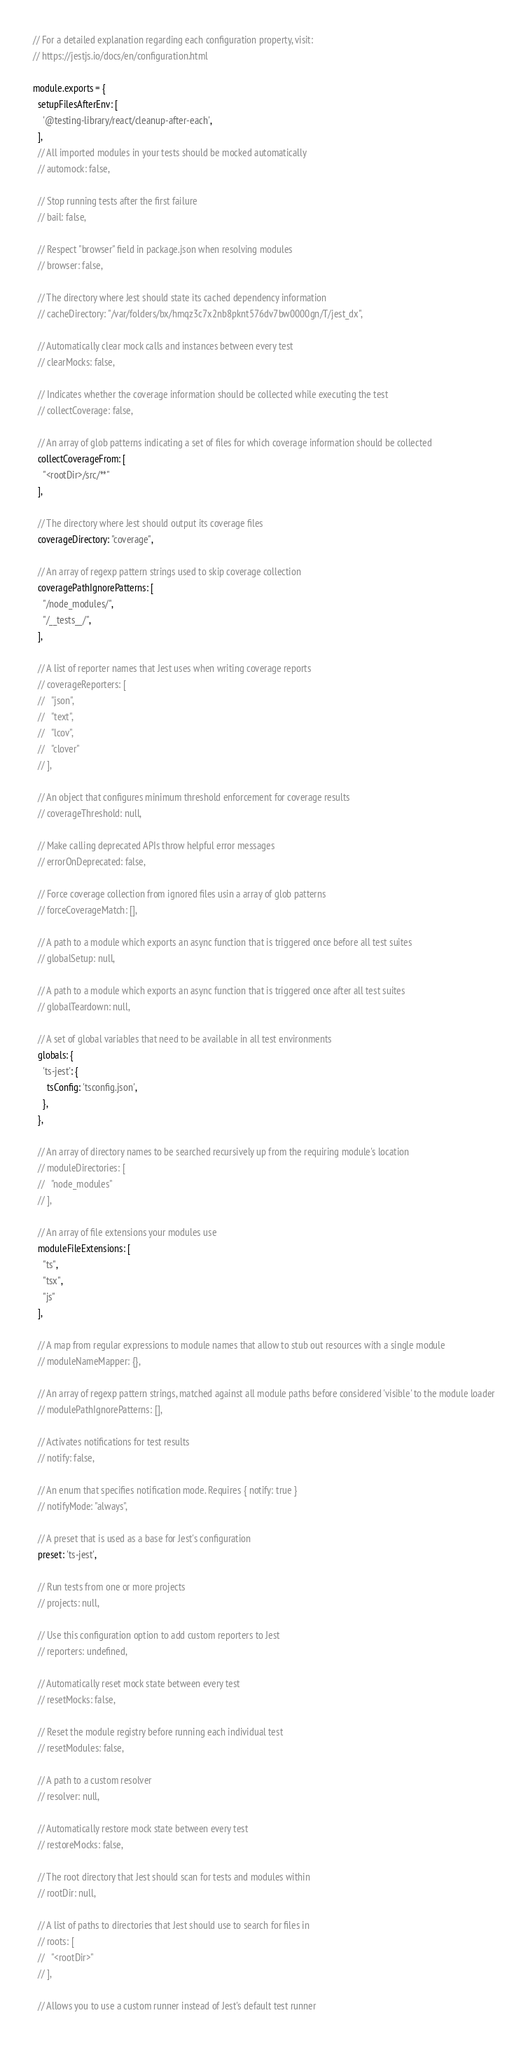Convert code to text. <code><loc_0><loc_0><loc_500><loc_500><_JavaScript_>// For a detailed explanation regarding each configuration property, visit:
// https://jestjs.io/docs/en/configuration.html

module.exports = {
  setupFilesAfterEnv: [
    '@testing-library/react/cleanup-after-each',
  ],
  // All imported modules in your tests should be mocked automatically
  // automock: false,

  // Stop running tests after the first failure
  // bail: false,

  // Respect "browser" field in package.json when resolving modules
  // browser: false,

  // The directory where Jest should state its cached dependency information
  // cacheDirectory: "/var/folders/bx/hmqz3c7x2nb8pknt576dv7bw0000gn/T/jest_dx",

  // Automatically clear mock calls and instances between every test
  // clearMocks: false,

  // Indicates whether the coverage information should be collected while executing the test
  // collectCoverage: false,

  // An array of glob patterns indicating a set of files for which coverage information should be collected
  collectCoverageFrom: [
    "<rootDir>/src/**"
  ],

  // The directory where Jest should output its coverage files
  coverageDirectory: "coverage",

  // An array of regexp pattern strings used to skip coverage collection
  coveragePathIgnorePatterns: [
    "/node_modules/",
    "/__tests__/",
  ],

  // A list of reporter names that Jest uses when writing coverage reports
  // coverageReporters: [
  //   "json",
  //   "text",
  //   "lcov",
  //   "clover"
  // ],

  // An object that configures minimum threshold enforcement for coverage results
  // coverageThreshold: null,

  // Make calling deprecated APIs throw helpful error messages
  // errorOnDeprecated: false,

  // Force coverage collection from ignored files usin a array of glob patterns
  // forceCoverageMatch: [],

  // A path to a module which exports an async function that is triggered once before all test suites
  // globalSetup: null,

  // A path to a module which exports an async function that is triggered once after all test suites
  // globalTeardown: null,

  // A set of global variables that need to be available in all test environments
  globals: {
    'ts-jest': {
      tsConfig: 'tsconfig.json',
    },
  },

  // An array of directory names to be searched recursively up from the requiring module's location
  // moduleDirectories: [
  //   "node_modules"
  // ],

  // An array of file extensions your modules use
  moduleFileExtensions: [
    "ts",
    "tsx",
    "js"
  ],

  // A map from regular expressions to module names that allow to stub out resources with a single module
  // moduleNameMapper: {},

  // An array of regexp pattern strings, matched against all module paths before considered 'visible' to the module loader
  // modulePathIgnorePatterns: [],

  // Activates notifications for test results
  // notify: false,

  // An enum that specifies notification mode. Requires { notify: true }
  // notifyMode: "always",

  // A preset that is used as a base for Jest's configuration
  preset: 'ts-jest',

  // Run tests from one or more projects
  // projects: null,

  // Use this configuration option to add custom reporters to Jest
  // reporters: undefined,

  // Automatically reset mock state between every test
  // resetMocks: false,

  // Reset the module registry before running each individual test
  // resetModules: false,

  // A path to a custom resolver
  // resolver: null,

  // Automatically restore mock state between every test
  // restoreMocks: false,

  // The root directory that Jest should scan for tests and modules within
  // rootDir: null,

  // A list of paths to directories that Jest should use to search for files in
  // roots: [
  //   "<rootDir>"
  // ],

  // Allows you to use a custom runner instead of Jest's default test runner</code> 